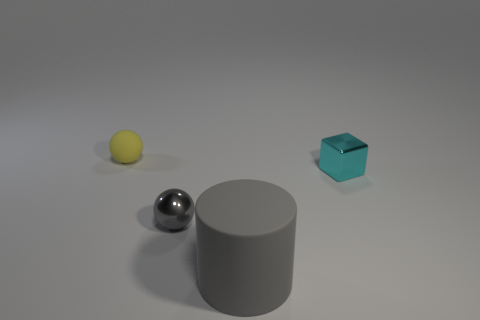There is a cylinder that is the same color as the small metal sphere; what material is it?
Your response must be concise. Rubber. Do the cyan object and the small yellow thing have the same shape?
Offer a very short reply. No. What number of big objects are either blue blocks or cyan metal cubes?
Make the answer very short. 0. There is a cyan shiny object; are there any gray metallic spheres right of it?
Offer a terse response. No. Are there an equal number of rubber cylinders in front of the gray cylinder and large blue metallic balls?
Make the answer very short. Yes. What size is the other thing that is the same shape as the small yellow thing?
Your answer should be very brief. Small. Do the yellow thing and the tiny object on the right side of the gray matte object have the same shape?
Provide a succinct answer. No. There is a object that is in front of the ball in front of the yellow matte sphere; what size is it?
Give a very brief answer. Large. Are there the same number of small spheres that are in front of the gray ball and tiny gray objects that are on the left side of the matte sphere?
Provide a succinct answer. Yes. There is another matte object that is the same shape as the small gray thing; what color is it?
Give a very brief answer. Yellow. 